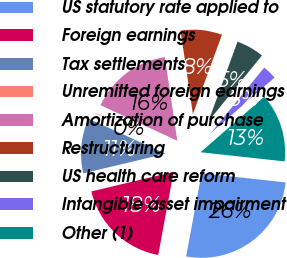<chart> <loc_0><loc_0><loc_500><loc_500><pie_chart><fcel>US statutory rate applied to<fcel>Foreign earnings<fcel>Tax settlements<fcel>Unremitted foreign earnings<fcel>Amortization of purchase<fcel>Restructuring<fcel>US health care reform<fcel>Intangible asset impairment<fcel>Other (1)<nl><fcel>26.19%<fcel>18.36%<fcel>10.53%<fcel>0.09%<fcel>15.75%<fcel>7.92%<fcel>5.31%<fcel>2.7%<fcel>13.14%<nl></chart> 